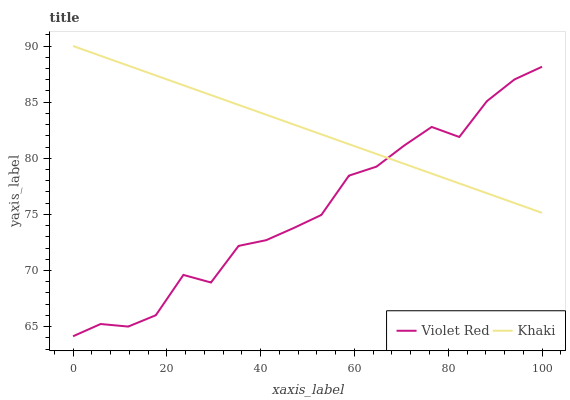Does Violet Red have the minimum area under the curve?
Answer yes or no. Yes. Does Khaki have the maximum area under the curve?
Answer yes or no. Yes. Does Khaki have the minimum area under the curve?
Answer yes or no. No. Is Khaki the smoothest?
Answer yes or no. Yes. Is Violet Red the roughest?
Answer yes or no. Yes. Is Khaki the roughest?
Answer yes or no. No. Does Khaki have the lowest value?
Answer yes or no. No. Does Khaki have the highest value?
Answer yes or no. Yes. Does Violet Red intersect Khaki?
Answer yes or no. Yes. Is Violet Red less than Khaki?
Answer yes or no. No. Is Violet Red greater than Khaki?
Answer yes or no. No. 